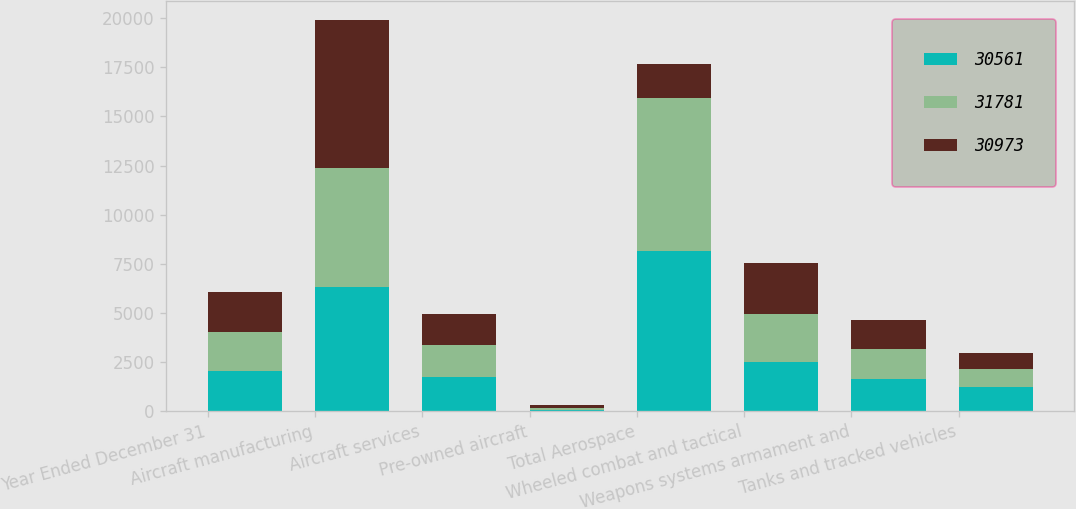<chart> <loc_0><loc_0><loc_500><loc_500><stacked_bar_chart><ecel><fcel>Year Ended December 31<fcel>Aircraft manufacturing<fcel>Aircraft services<fcel>Pre-owned aircraft<fcel>Total Aerospace<fcel>Wheeled combat and tactical<fcel>Weapons systems armament and<fcel>Tanks and tracked vehicles<nl><fcel>30561<fcel>2017<fcel>6320<fcel>1743<fcel>66<fcel>8129<fcel>2506<fcel>1633<fcel>1225<nl><fcel>31781<fcel>2016<fcel>6074<fcel>1625<fcel>116<fcel>7815<fcel>2444<fcel>1517<fcel>934<nl><fcel>30973<fcel>2015<fcel>7497<fcel>1569<fcel>111<fcel>1743<fcel>2597<fcel>1508<fcel>805<nl></chart> 